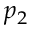Convert formula to latex. <formula><loc_0><loc_0><loc_500><loc_500>p _ { 2 }</formula> 